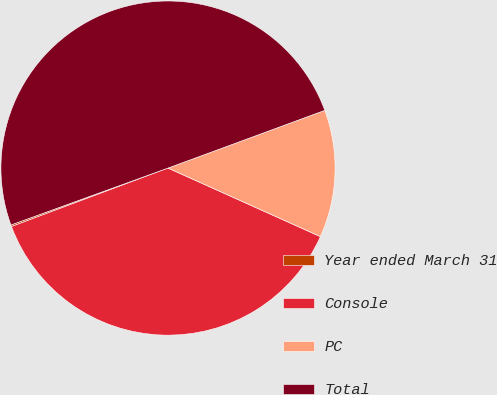<chart> <loc_0><loc_0><loc_500><loc_500><pie_chart><fcel>Year ended March 31<fcel>Console<fcel>PC<fcel>Total<nl><fcel>0.16%<fcel>37.58%<fcel>12.34%<fcel>49.92%<nl></chart> 